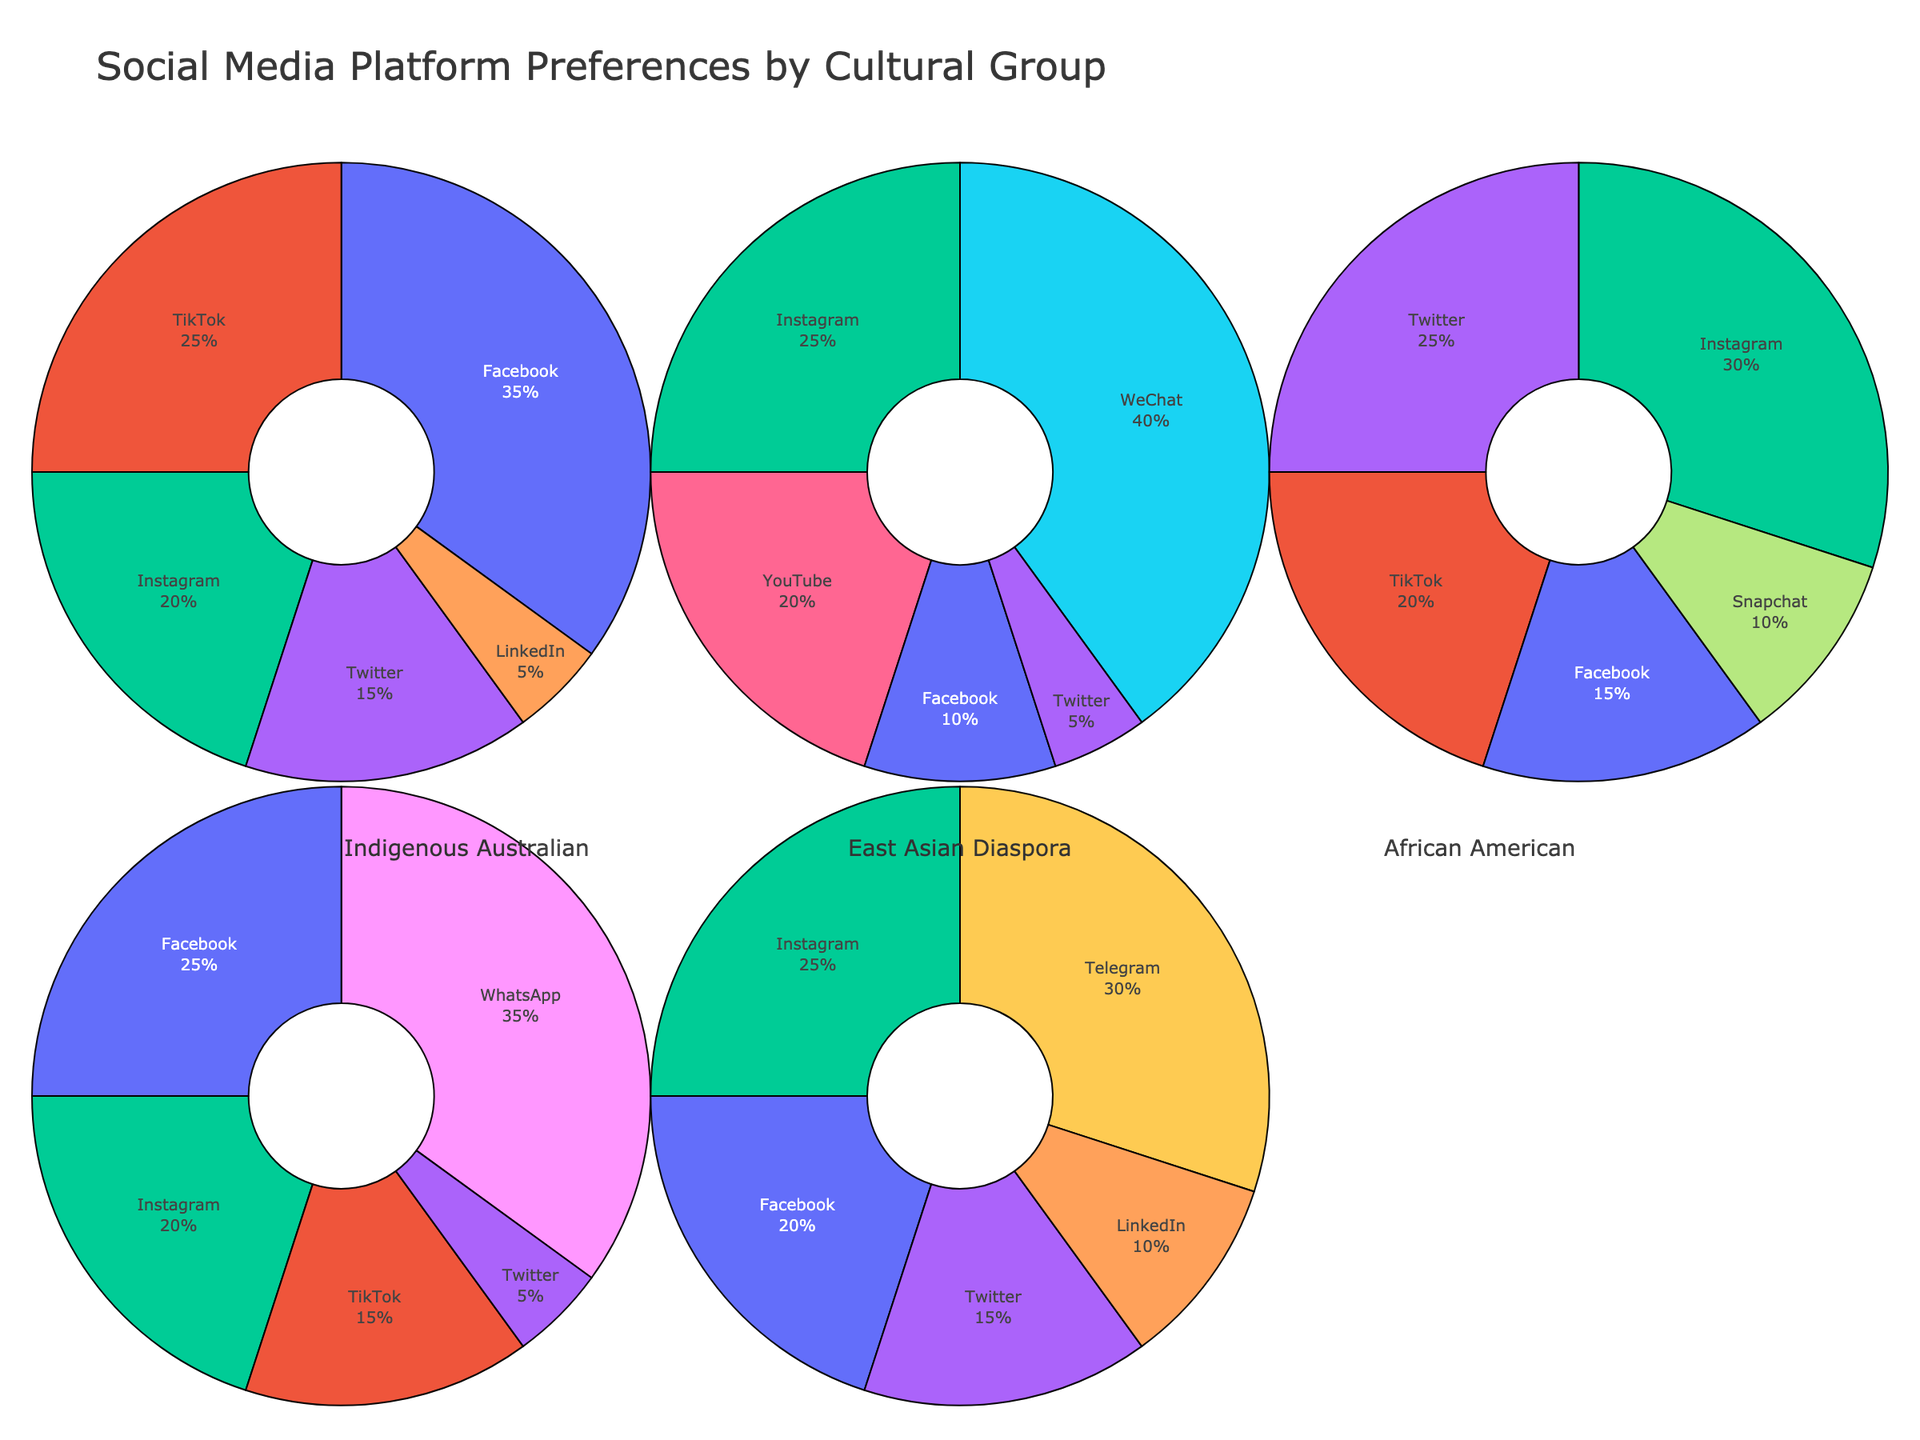Which cultural group prefers Instagram the most? To determine which cultural group prefers Instagram the most, look for the pie chart with the largest segment labeled Instagram. The African American pie chart has the largest Instagram segment at 30%.
Answer: African American Which social media platform is least preferred by the Indigenous Australian group? Identify the smallest segment in the Indigenous Australian pie chart. The smallest segment is LinkedIn at 5%.
Answer: LinkedIn What percentage of the Latin American group prefers WhatsApp? Locate the WhatsApp segment in the Latin American pie chart. The WhatsApp segment is 35%.
Answer: 35% Compare the percentage of Facebook users between the Indigenous Australian and East Asian Diaspora groups. Which group has a higher percentage? Check the Facebook segments in both the Indigenous Australian and East Asian Diaspora pie charts. Indigenous Australian has 35%, while East Asian Diaspora has 10%. Therefore, the Indigenous Australian group has a higher percentage.
Answer: Indigenous Australian How does the preference for Twitter in the Middle Eastern group compare to that in the African American group? Look at the Twitter segments in both the Middle Eastern and African American pie charts. Middle Eastern has 15%, while African American has 25%. The African American group has a higher percentage.
Answer: African American Which platform is preferred by 40% of the East Asian Diaspora group? Find the segment that occupies 40% of the East Asian Diaspora pie chart. The segment is labeled WeChat.
Answer: WeChat What is the combined percentage of TikTok and Instagram users in the Indigenous Australian group? Add the percentages of the TikTok and Instagram segments in the Indigenous Australian pie chart. TikTok is 25% and Instagram is 20%, so the combined percentage is 25 + 20 = 45%.
Answer: 45% Which cultural group has the highest percentage of YouTube users? Identify the pie chart with the largest YouTube segment. The East Asian Diaspora group has a YouTube segment of 20%, which is the highest among all groups.
Answer: East Asian Diaspora Is the Facebook preference in the Latin American group greater than the combined Twitter and LinkedIn preference in the Middle Eastern group? Compare the Facebook segment in the Latin American pie chart (25%) with the sum of the Twitter (15%) and LinkedIn (10%) segments in the Middle Eastern pie chart. The sum for Middle Eastern is 15 + 10 = 25%. Therefore, both percentages are equal.
Answer: No, they are equal What is the difference in percentage between the most preferred and least preferred platforms for the Indigenous Australian group? Find the highest percentage (Facebook 35%) and the lowest percentage (LinkedIn 5%) in the Indigenous Australian pie chart, then calculate the difference, which is 35 - 5 = 30%.
Answer: 30% 